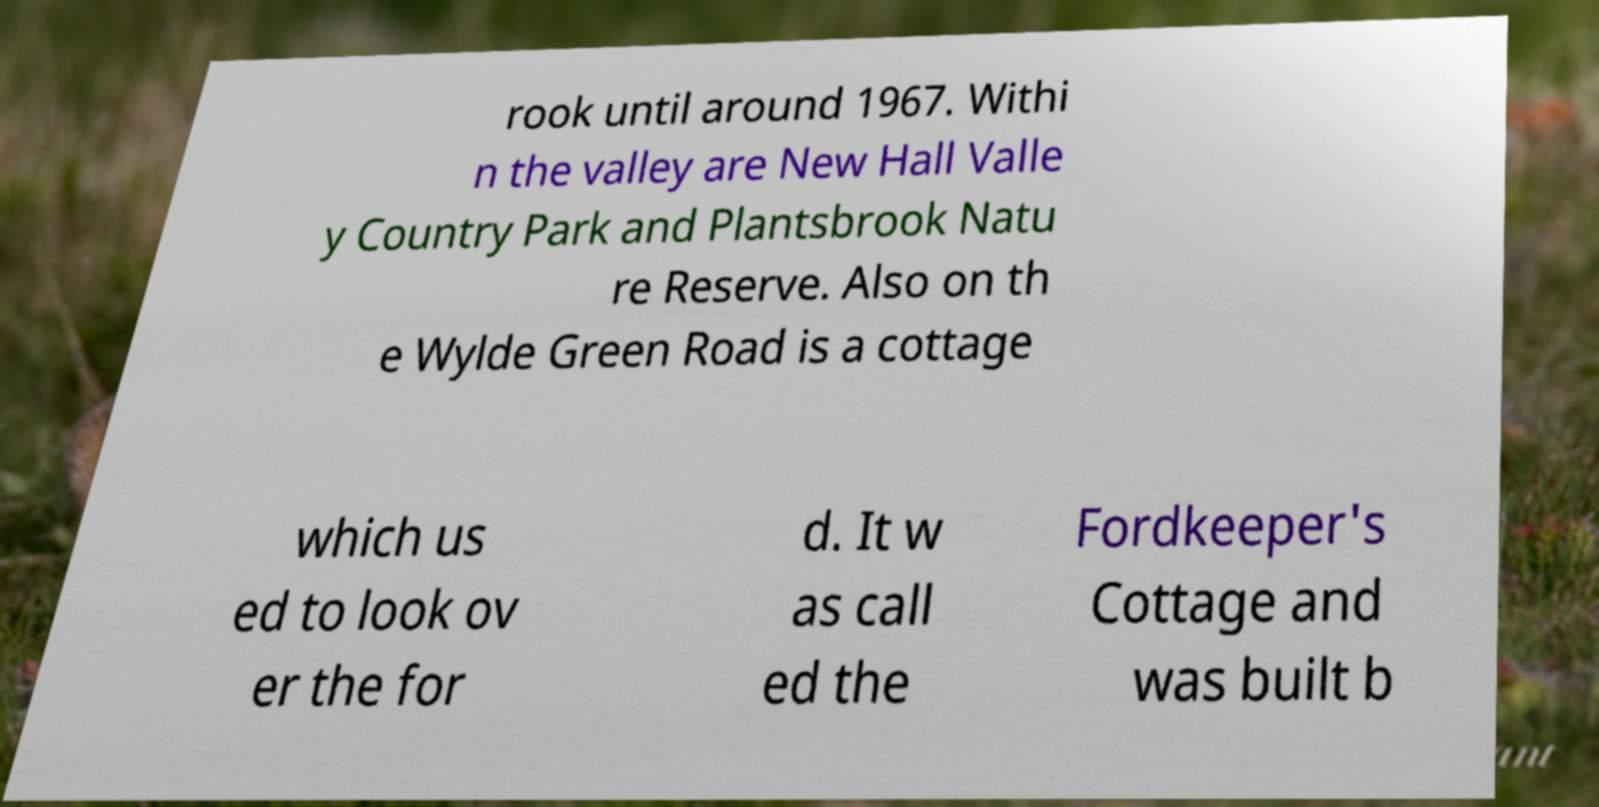What messages or text are displayed in this image? I need them in a readable, typed format. rook until around 1967. Withi n the valley are New Hall Valle y Country Park and Plantsbrook Natu re Reserve. Also on th e Wylde Green Road is a cottage which us ed to look ov er the for d. It w as call ed the Fordkeeper's Cottage and was built b 